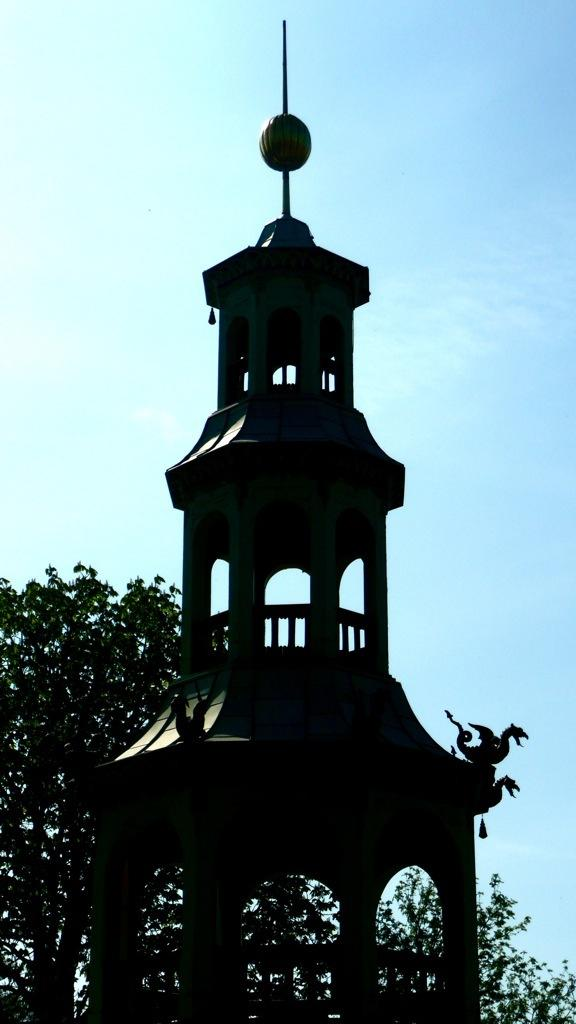What type of structure can be seen in the picture? There is an architectural structure in the picture. What other elements are present in the picture besides the structure? There are trees in the picture. What can be seen in the background of the picture? The sky is visible in the background of the picture. What type of popcorn can be seen falling from the sky in the image? There is no popcorn present in the image; it only features an architectural structure, trees, and the sky. 